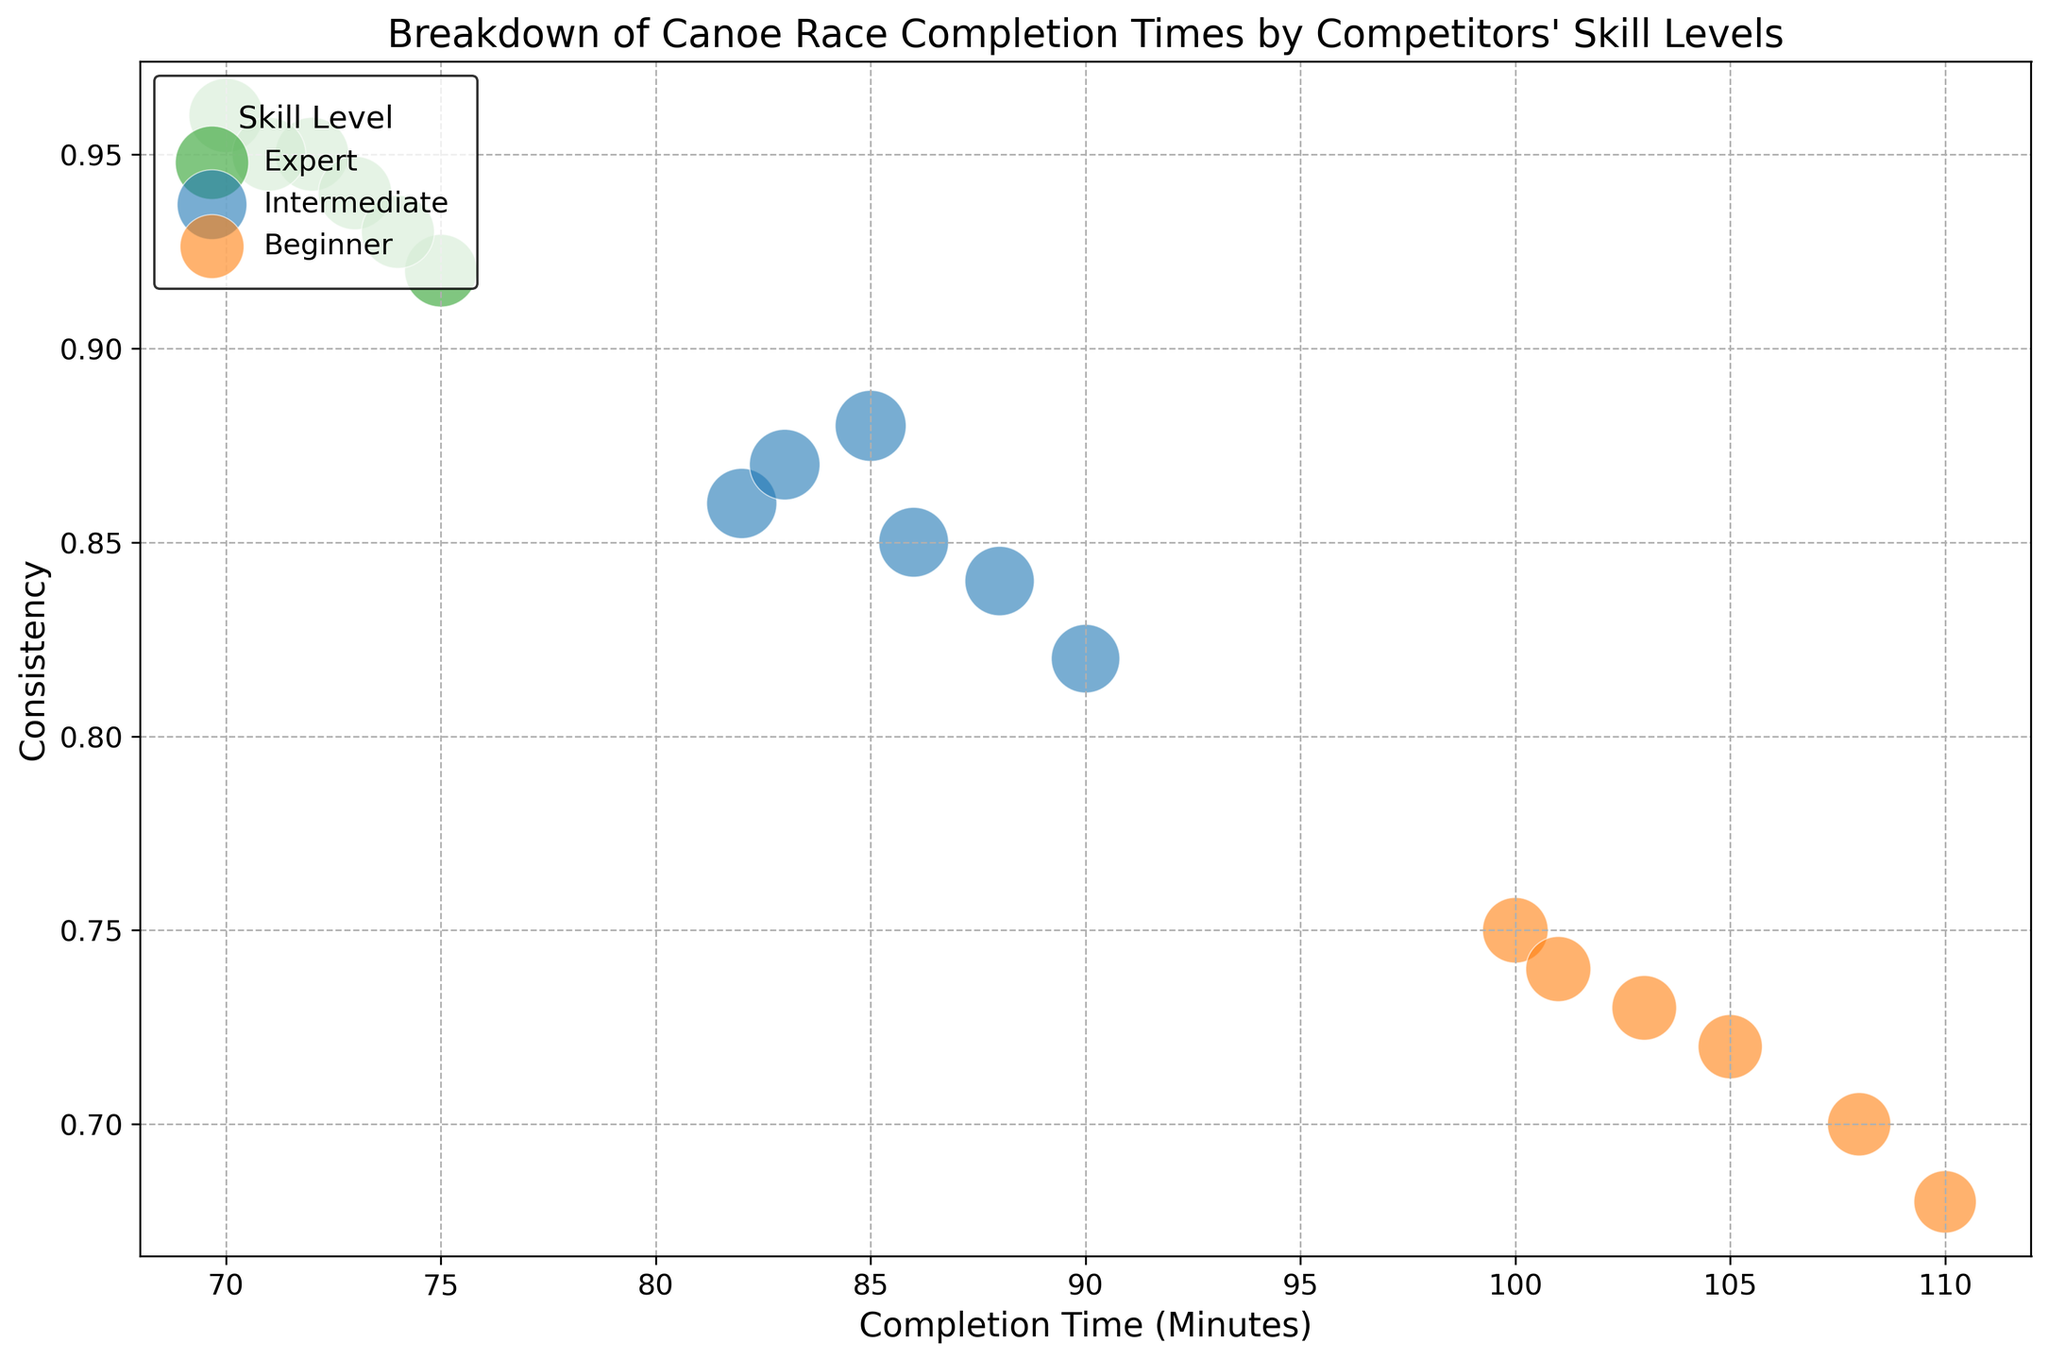What is the consistency of the beginner with the highest completion time? To find the beginner with the highest completion time, we look for the highest value on the x-axis among the beginners. This value is 110 (Daniel Moore). The corresponding consistency (y-axis) for this point is 0.68.
Answer: 0.68 Whose completion time is the shortest among the experts? In the expert group, we look for the lowest value on the x-axis. The shortest completion time among experts is 70 (Chris Evans).
Answer: Chris Evans Which skill level group has the widest range of completion times? By visually inspecting the bubble lengths on the x-axis, we should calculate the range (maximum completion time - minimum completion time) for each skill level. Experts range from 70 to 75 (5 minutes), Intermediates from 82 to 90 (8 minutes), and Beginners from 100 to 110 (10 minutes). Beginners have the widest range.
Answer: Beginners What is the average consistency of all intermediate competitors? For intermediate competitors, we sum their consistencies (0.88 + 0.86 + 0.84 + 0.87 + 0.85 + 0.82) and divide by their number (6). The average consistency is (5.12 / 6), which equals approximately 0.853.
Answer: 0.853 Are there more experts or beginners with consistency greater than 0.90? We count the number of bubbles for experts and beginners that are above 0.90 on the y-axis. For experts: 5 (John Doe, Jane Smith, Chris Evans, Sophia Taylor, Matthew Jackson). For beginners: 0. There are more experts with consistency greater than 0.90.
Answer: Experts How many competitors have a completion time under 80 minutes, and how many of them are experts? We count the bubbles left of the 80-minute mark on the x-axis, noticing which are colored green for experts. There are 5 competitors under 80 minutes (John Doe, Jane Smith, Chris Evans, Sophia Taylor, Matthew Jackson), all experts.
Answer: 5 competitors, all experts Which competitor is the least consistent among those with the highest completion times? Checking the far right bubbles on the x-axis (Daniel Moore with 110 minutes, Sarah Wilson with 105 minutes, Emma Thomas with 108 minutes), we look for the lowest y-axis value. Daniel Moore (0.68) is the least consistent.
Answer: Daniel Moore What is the most common consistency range for intermediate competitors? For intermediate competitors, check the y-axis range. Most are within the 0.82 to 0.88 range.
Answer: 0.82 to 0.88 How does the consistency of the top-performing expert compare to the top-performing beginner? The lowest (top-performing) completion times for experts and beginners are 70 (Chris Evans) and 100 (Joshua Davis) respectively. Their consistencies are 0.96 (Chris Evans) and 0.75 (Joshua Davis). Chris Evans has a much higher consistency.
Answer: Chris Evans is much higher 